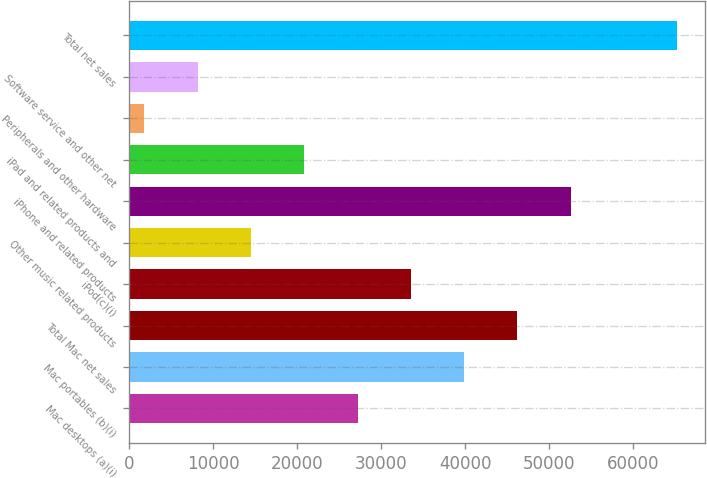<chart> <loc_0><loc_0><loc_500><loc_500><bar_chart><fcel>Mac desktops (a)(i)<fcel>Mac portables (b)(i)<fcel>Total Mac net sales<fcel>iPod(c)(i)<fcel>Other music related products<fcel>iPhone and related products<fcel>iPad and related products and<fcel>Peripherals and other hardware<fcel>Software service and other net<fcel>Total net sales<nl><fcel>27178.4<fcel>39860.6<fcel>46201.7<fcel>33519.5<fcel>14496.2<fcel>52542.8<fcel>20837.3<fcel>1814<fcel>8155.1<fcel>65225<nl></chart> 